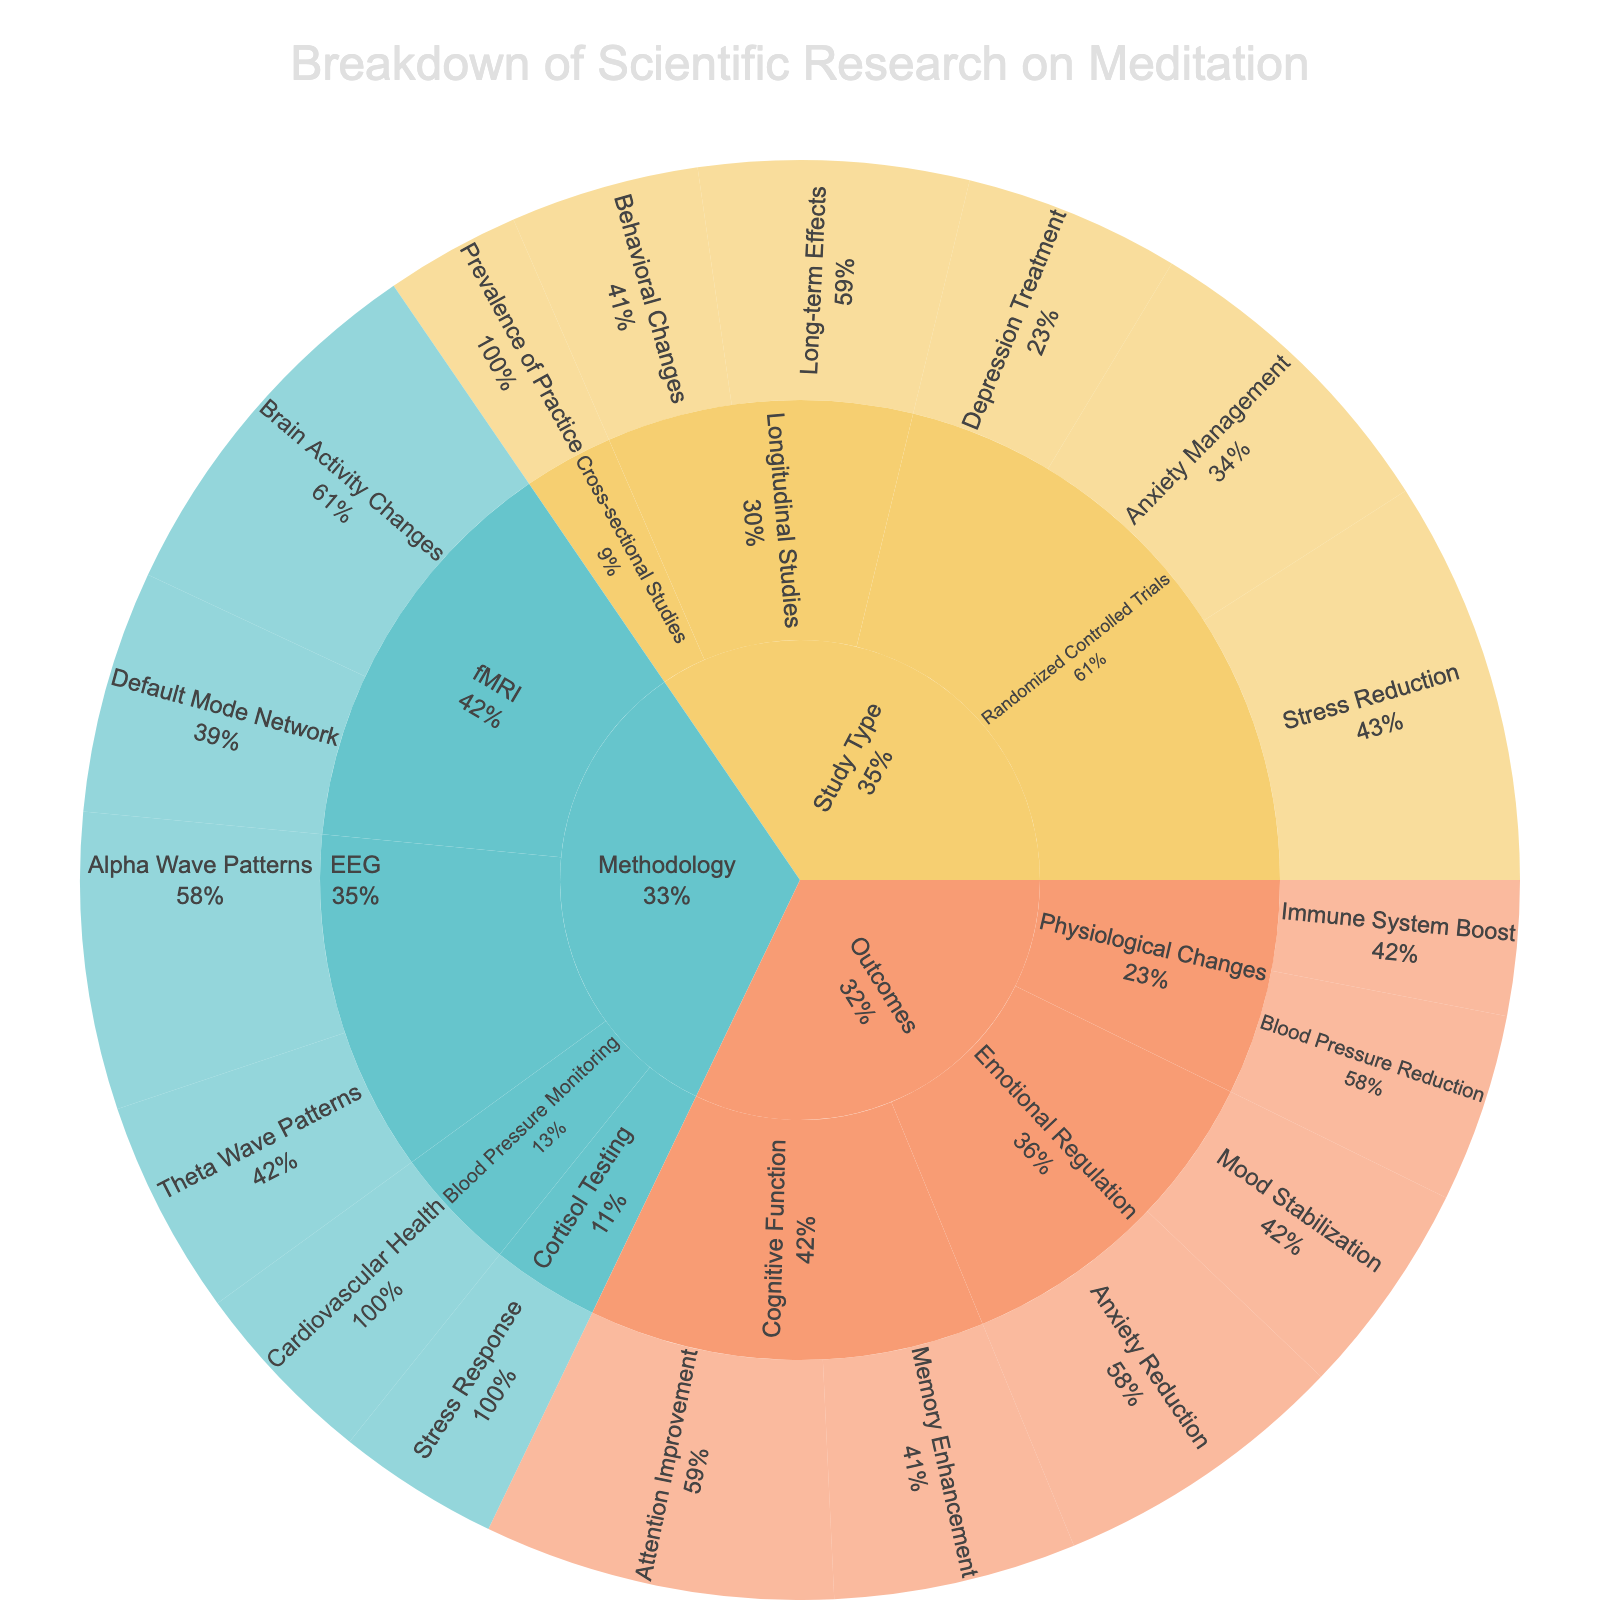What is the main title of the figure? The main title usually appears prominently and provides an overview of the visual content. In this case, it encompasses the overall theme of the research breakdown.
Answer: Breakdown of Scientific Research on Meditation How many subcategories of 'Study Type' are there? Identify the number of different subcategories by looking at the levels branching from 'Study Type'.
Answer: 3 Which subcategory under 'Methodology' has the highest number of studies? Compare the values associated with each subsubcategory under 'Methodology' to determine the largest one.
Answer: fMRI How many studies are dedicated to 'Stress Reduction' under 'Randomized Controlled Trials'? Look for the 'Stress Reduction' subsubcategory under 'Randomized Controlled Trials' and note its value.
Answer: 15 What are the total studies focusing on 'Emotional Regulation'? Sum the studies in 'Anxiety Reduction' and 'Mood Stabilization', both of which fall under 'Emotional Regulation'.
Answer: 11 + 8 = 19 Which study type has the lowest total number of studies? Calculate the sum of studies for each study type and determine the smallest. Sum of Randomized Controlled Trials: 15+12+8=35, Longitudinal Studies: 10+7=17, Cross-sectional Studies: 5.
Answer: Cross-sectional Studies with 5 What is the combined total of studies related to 'Cognitive Function'? Add the values of the subsubcategories (Attention Improvement and Memory Enhancement) under 'Cognitive Function'.
Answer: 13 + 9 = 22 Compare the number of studies under 'EEG' with those focused on 'Cognitive Function'. Which has more? Sum the studies in 'EEG' (Alpha Wave Patterns and Theta Wave Patterns) and compare to the total under 'Cognitive Function'. EEG: 11 + 8 = 19, Cognitive Function: 22.
Answer: Cognitive Function with 22 Which outcome has the fewest studies, 'Blood Pressure Reduction' or 'Immune System Boost'? Compare the values of these specific subsubcategories under 'Physiological Changes'.
Answer: Immune System Boost with 5 What percentage of the 'Randomized Controlled Trials' are dedicated to 'Anxiety Management'? Use the value for 'Anxiety Management' (12) and divide by the total 'Randomized Controlled Trials' (35), then multiply by 100 to get the percentage.
Answer: (12/35) * 100 ≈ 34.29% 